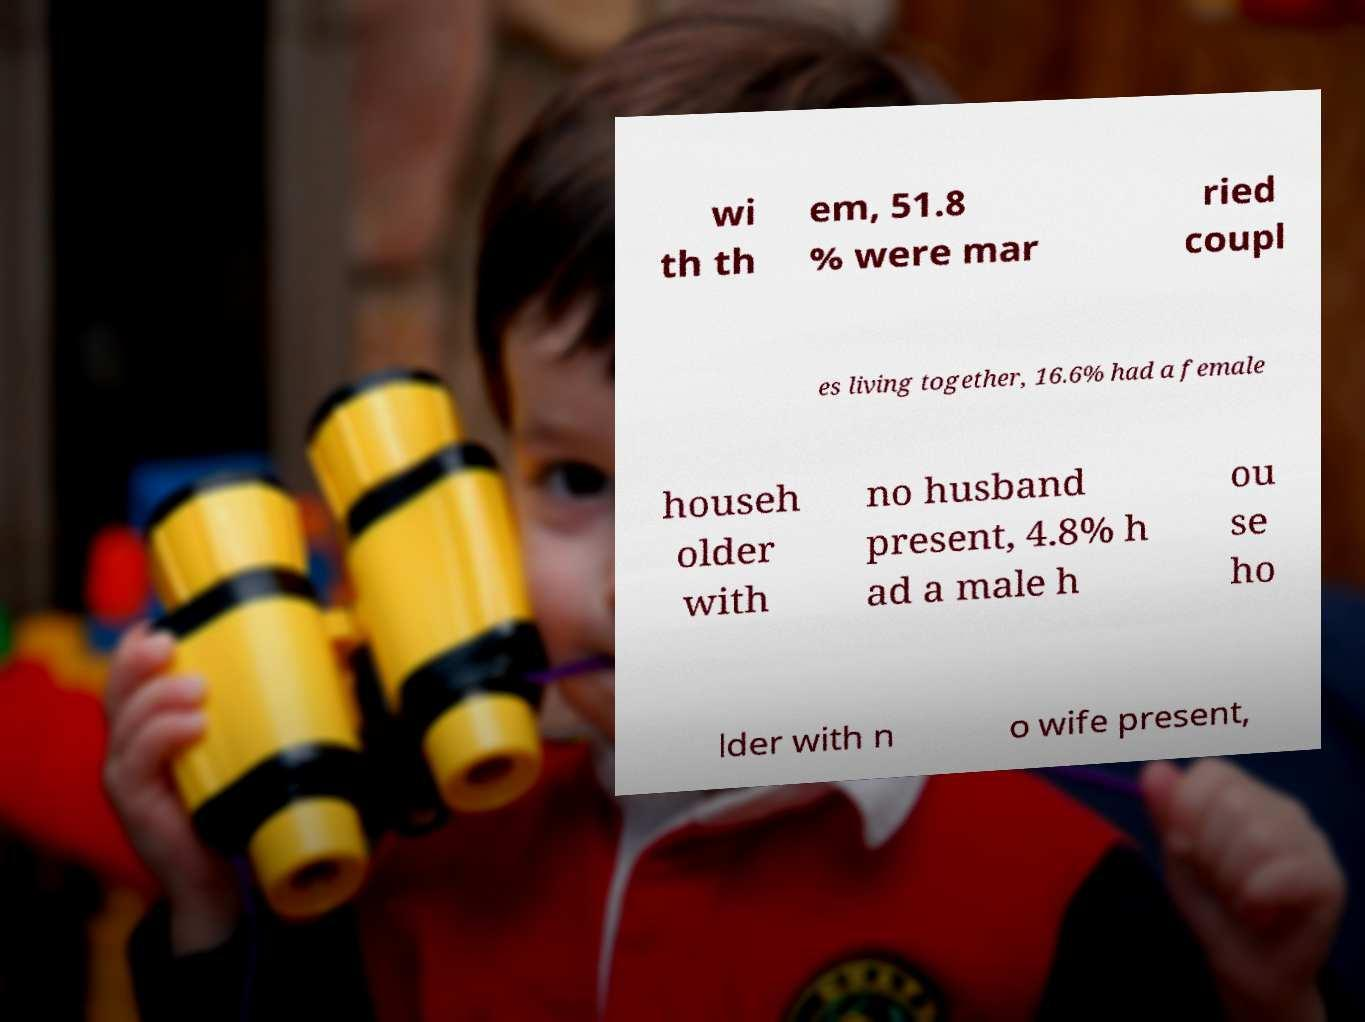Can you accurately transcribe the text from the provided image for me? wi th th em, 51.8 % were mar ried coupl es living together, 16.6% had a female househ older with no husband present, 4.8% h ad a male h ou se ho lder with n o wife present, 